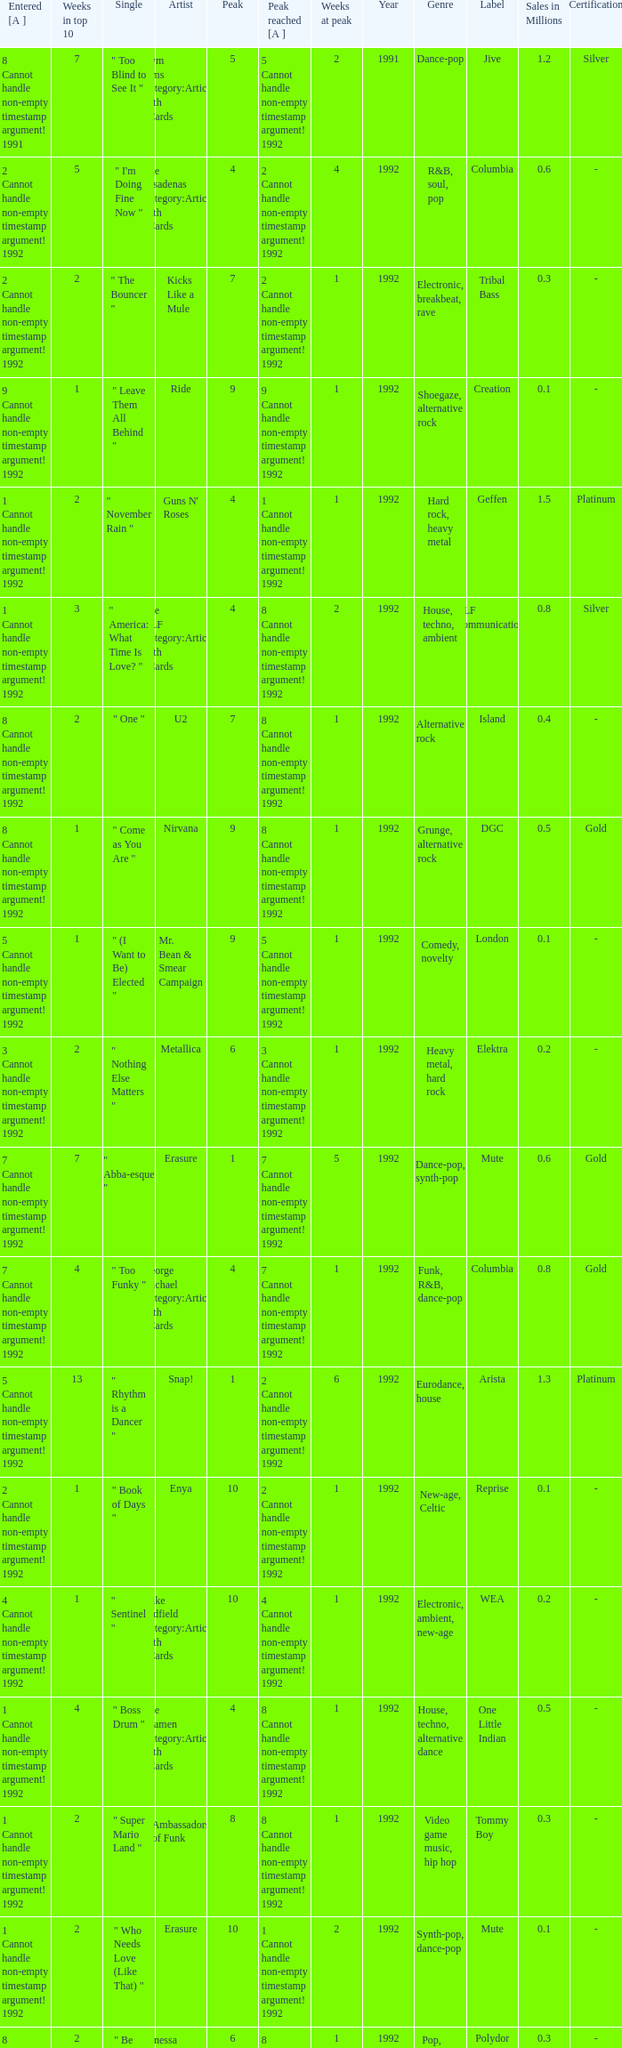Can you give me this table as a dict? {'header': ['Entered [A ]', 'Weeks in top 10', 'Single', 'Artist', 'Peak', 'Peak reached [A ]', 'Weeks at peak', 'Year', 'Genre', 'Label', 'Sales in Millions', 'Certification'], 'rows': [['8 Cannot handle non-empty timestamp argument! 1991', '7', '" Too Blind to See It "', 'Kym Sims Category:Articles with hCards', '5', '5 Cannot handle non-empty timestamp argument! 1992', '2', '1991', 'Dance-pop', 'Jive', '1.2', 'Silver'], ['2 Cannot handle non-empty timestamp argument! 1992', '5', '" I\'m Doing Fine Now "', 'The Pasadenas Category:Articles with hCards', '4', '2 Cannot handle non-empty timestamp argument! 1992', '4', '1992', 'R&B, soul, pop', 'Columbia', '0.6', '-'], ['2 Cannot handle non-empty timestamp argument! 1992', '2', '" The Bouncer "', 'Kicks Like a Mule', '7', '2 Cannot handle non-empty timestamp argument! 1992', '1', '1992', 'Electronic, breakbeat, rave', 'Tribal Bass', '0.3', '-'], ['9 Cannot handle non-empty timestamp argument! 1992', '1', '" Leave Them All Behind "', 'Ride', '9', '9 Cannot handle non-empty timestamp argument! 1992', '1', '1992', 'Shoegaze, alternative rock', 'Creation', '0.1', '-'], ['1 Cannot handle non-empty timestamp argument! 1992', '2', '" November Rain "', "Guns N' Roses", '4', '1 Cannot handle non-empty timestamp argument! 1992', '1', '1992', 'Hard rock, heavy metal', 'Geffen', '1.5', 'Platinum'], ['1 Cannot handle non-empty timestamp argument! 1992', '3', '" America: What Time Is Love? "', 'The KLF Category:Articles with hCards', '4', '8 Cannot handle non-empty timestamp argument! 1992', '2', '1992', 'House, techno, ambient', 'KLF Communications', '0.8', 'Silver'], ['8 Cannot handle non-empty timestamp argument! 1992', '2', '" One "', 'U2', '7', '8 Cannot handle non-empty timestamp argument! 1992', '1', '1992', 'Alternative rock', 'Island', '0.4', '-'], ['8 Cannot handle non-empty timestamp argument! 1992', '1', '" Come as You Are "', 'Nirvana', '9', '8 Cannot handle non-empty timestamp argument! 1992', '1', '1992', 'Grunge, alternative rock', 'DGC', '0.5', 'Gold'], ['5 Cannot handle non-empty timestamp argument! 1992', '1', '" (I Want to Be) Elected "', 'Mr. Bean & Smear Campaign', '9', '5 Cannot handle non-empty timestamp argument! 1992', '1', '1992', 'Comedy, novelty', 'London', '0.1', '-'], ['3 Cannot handle non-empty timestamp argument! 1992', '2', '" Nothing Else Matters "', 'Metallica', '6', '3 Cannot handle non-empty timestamp argument! 1992', '1', '1992', 'Heavy metal, hard rock', 'Elektra', '0.2', '-'], ['7 Cannot handle non-empty timestamp argument! 1992', '7', '" Abba-esque "', 'Erasure', '1', '7 Cannot handle non-empty timestamp argument! 1992', '5', '1992', 'Dance-pop, synth-pop', 'Mute', '0.6', 'Gold'], ['7 Cannot handle non-empty timestamp argument! 1992', '4', '" Too Funky "', 'George Michael Category:Articles with hCards', '4', '7 Cannot handle non-empty timestamp argument! 1992', '1', '1992', 'Funk, R&B, dance-pop', 'Columbia', '0.8', 'Gold'], ['5 Cannot handle non-empty timestamp argument! 1992', '13', '" Rhythm is a Dancer "', 'Snap!', '1', '2 Cannot handle non-empty timestamp argument! 1992', '6', '1992', 'Eurodance, house', 'Arista', '1.3', 'Platinum'], ['2 Cannot handle non-empty timestamp argument! 1992', '1', '" Book of Days "', 'Enya', '10', '2 Cannot handle non-empty timestamp argument! 1992', '1', '1992', 'New-age, Celtic', 'Reprise', '0.1', '-'], ['4 Cannot handle non-empty timestamp argument! 1992', '1', '" Sentinel "', 'Mike Oldfield Category:Articles with hCards', '10', '4 Cannot handle non-empty timestamp argument! 1992', '1', '1992', 'Electronic, ambient, new-age', 'WEA', '0.2', '-'], ['1 Cannot handle non-empty timestamp argument! 1992', '4', '" Boss Drum "', 'The Shamen Category:Articles with hCards', '4', '8 Cannot handle non-empty timestamp argument! 1992', '1', '1992', 'House, techno, alternative dance', 'One Little Indian', '0.5', '-'], ['1 Cannot handle non-empty timestamp argument! 1992', '2', '" Super Mario Land "', 'Ambassadors of Funk', '8', '8 Cannot handle non-empty timestamp argument! 1992', '1', '1992', 'Video game music, hip hop', 'Tommy Boy', '0.3', '-'], ['1 Cannot handle non-empty timestamp argument! 1992', '2', '" Who Needs Love (Like That) "', 'Erasure', '10', '1 Cannot handle non-empty timestamp argument! 1992', '2', '1992', 'Synth-pop, dance-pop', 'Mute', '0.1', '-'], ['8 Cannot handle non-empty timestamp argument! 1992', '2', '" Be My Baby "', 'Vanessa Paradis Category:Articles with hCards', '6', '8 Cannot handle non-empty timestamp argument! 1992', '1', '1992', 'Pop, folk-pop', 'Polydor', '0.3', '-'], ['6 Cannot handle non-empty timestamp argument! 1992', '5', '" Slam Jam "', 'WWF Superstars', '4', '6 Cannot handle non-empty timestamp argument! 1992', '2', '1992', 'Pro-wrestling, hip hop', 'Columbia', '0.2', '-']]} If the peak reached is 6 cannot handle non-empty timestamp argument! 1992, what is the entered? 6 Cannot handle non-empty timestamp argument! 1992. 